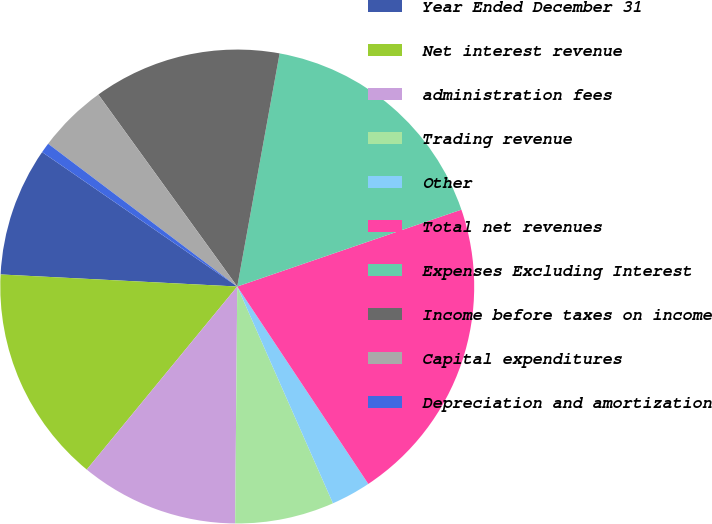Convert chart. <chart><loc_0><loc_0><loc_500><loc_500><pie_chart><fcel>Year Ended December 31<fcel>Net interest revenue<fcel>administration fees<fcel>Trading revenue<fcel>Other<fcel>Total net revenues<fcel>Expenses Excluding Interest<fcel>Income before taxes on income<fcel>Capital expenditures<fcel>Depreciation and amortization<nl><fcel>8.79%<fcel>14.86%<fcel>10.81%<fcel>6.76%<fcel>2.71%<fcel>20.93%<fcel>16.88%<fcel>12.83%<fcel>4.74%<fcel>0.69%<nl></chart> 